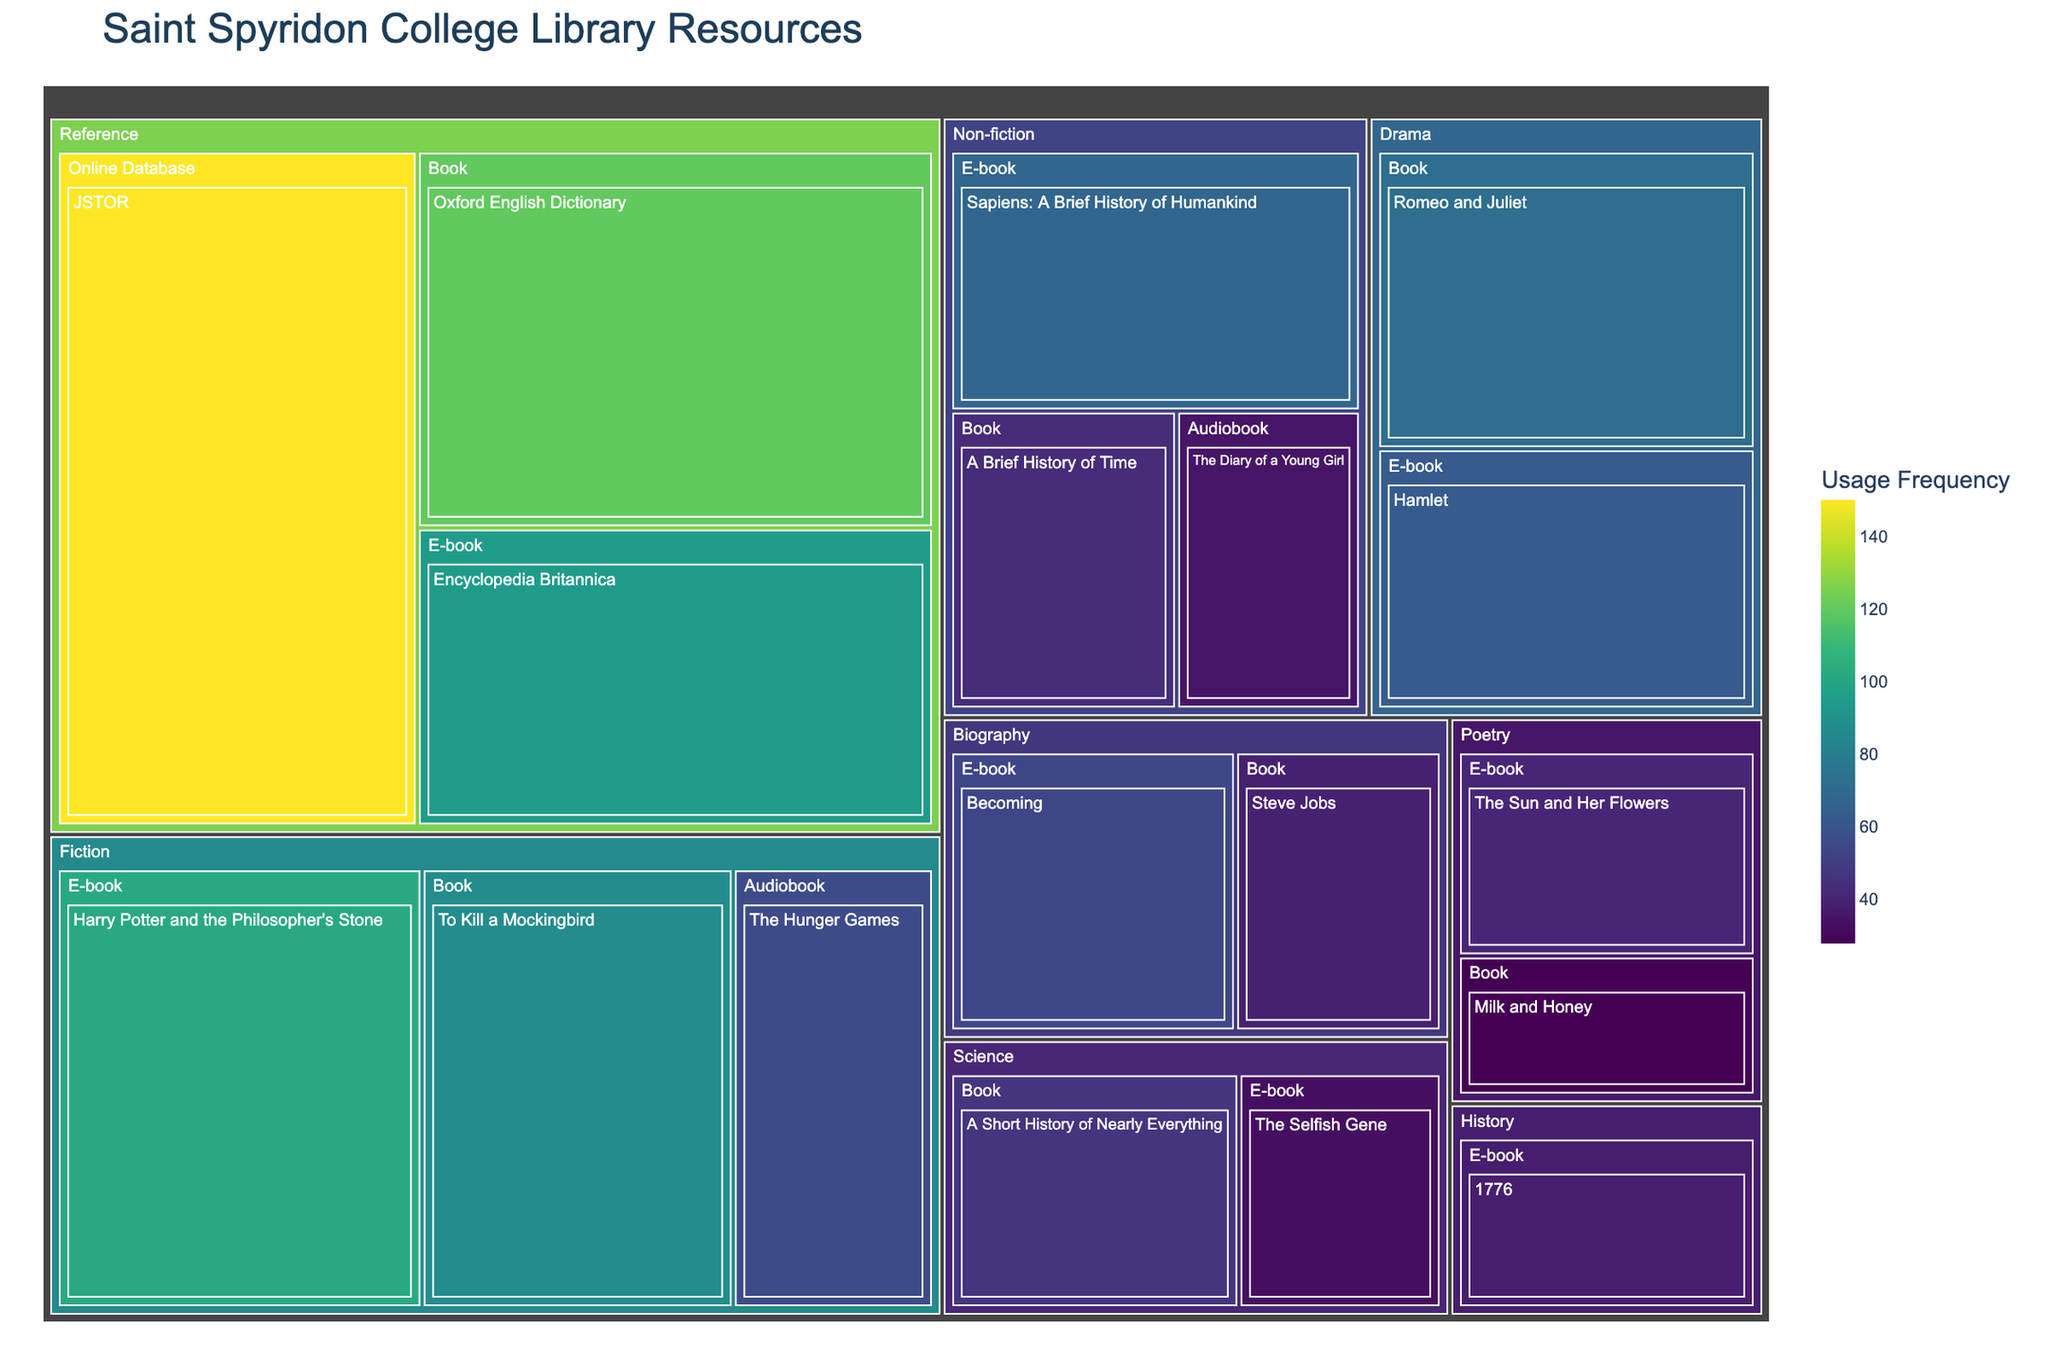What's the library resource with the highest usage frequency? The treemap color scale indicates that the darkest tile represents the item with the highest usage frequency. By observing the colors and labels, the resource "JSTOR" under the "Reference" genre is the darkest and indicates the highest value.
Answer: JSTOR In which genre is the "Oxford English Dictionary" classified and what is its usage frequency? Locate the "Oxford English Dictionary" tile in the treemap, which is under the "Reference" genre section. The label on this tile shows its usage frequency.
Answer: Reference, 120 Which e-book has the highest usage frequency in the Fiction genre? Navigate to the "Fiction" genre section and compare e-books. The e-book with the highest usage frequency is "Harry Potter and the Philosopher's Stone" with a frequency of 102.
Answer: Harry Potter and the Philosopher's Stone How do the usage frequencies of "A Brief History of Time" and "The Selfish Gene" compare? Identify the tiles for "A Brief History of Time" (Non-fiction, Book) and "The Selfish Gene" (Science, E-book). Compare the usage frequency values listed on their respective tiles.
Answer: A Brief History of Time: 43, The Selfish Gene: 33 What's the average usage frequency of e-books across all genres? Extract the usage frequencies of all e-books: 102, 68, 95, 41, 63, 54, 33, 38. Sum these values (494) and divide by the number of e-books (8).
Answer: 61.75 Which format has the most entries in the treemap, and how many are there? Count the number of titles in each format: Book, E-book, Audiobook, Online Database. E-book appears most frequently with 7 entries.
Answer: E-book, 7 What is the total usage frequency of all formats within the "Drama" genre? Add the usage frequencies of "Romeo and Juliet" (72) and "Hamlet" (63). The total is 72 + 63.
Answer: 135 How does the usage frequency of "Milk and Honey" compare to the other resources in the Poetry genre? Identify the other resources in the Poetry genre. "Milk and Honey" usage frequency (28) is less than "The Sun and Her Flowers" (41).
Answer: Less than The Sun and Her Flowers Which genre has the highest overall usage frequency? Sum the usage frequencies within each genre. The Reference genre has the highest sum: 120 (Oxford English Dictionary) + 95 (Encyclopedia Britannica) + 150 (JSTOR) = 365.
Answer: Reference What is the combined usage frequency of all audiobooks in the library? Sum the usage frequencies of all audiobooks: The Hunger Games (56), The Diary of a Young Girl (35). The total is 56 + 35.
Answer: 91 